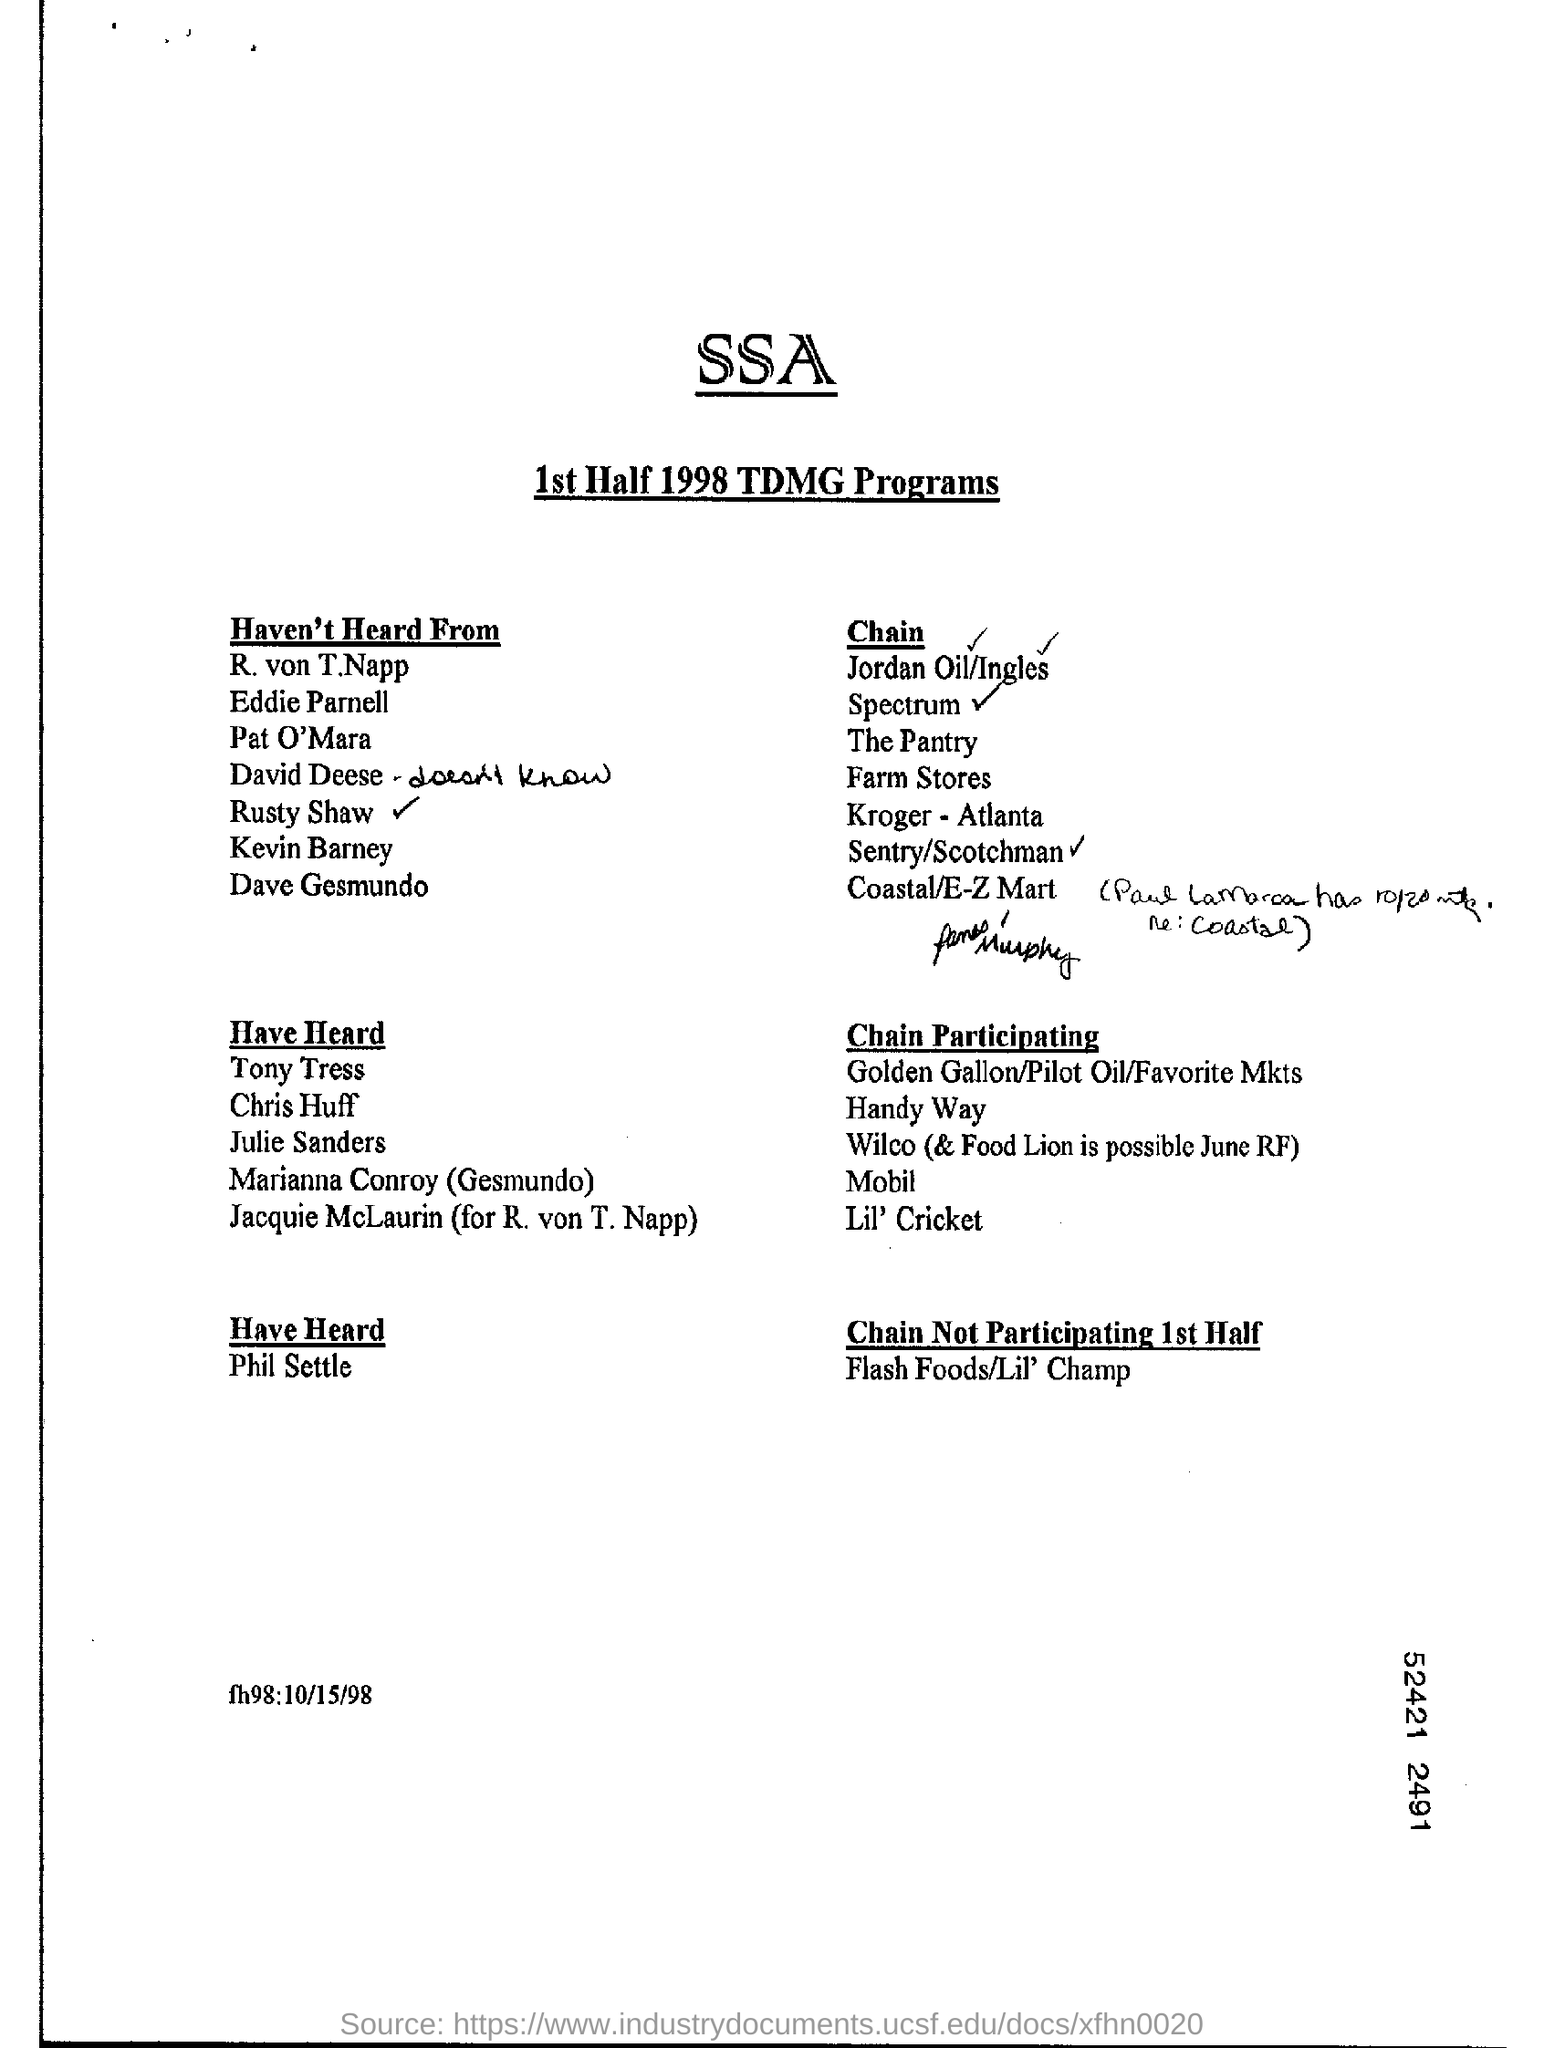Mention a couple of crucial points in this snapshot. The person listed first in the 'haven't heard from' list is R. von T.Napp. The main heading is "What is the main heading? SSA.. 